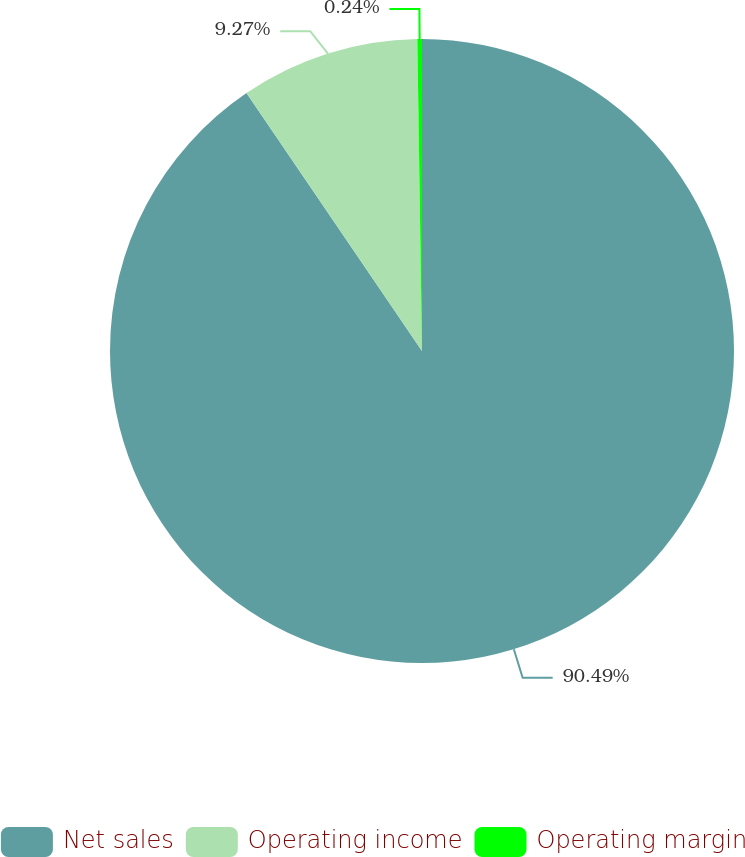<chart> <loc_0><loc_0><loc_500><loc_500><pie_chart><fcel>Net sales<fcel>Operating income<fcel>Operating margin<nl><fcel>90.49%<fcel>9.27%<fcel>0.24%<nl></chart> 